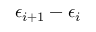<formula> <loc_0><loc_0><loc_500><loc_500>\epsilon _ { i + 1 } - \epsilon _ { i }</formula> 